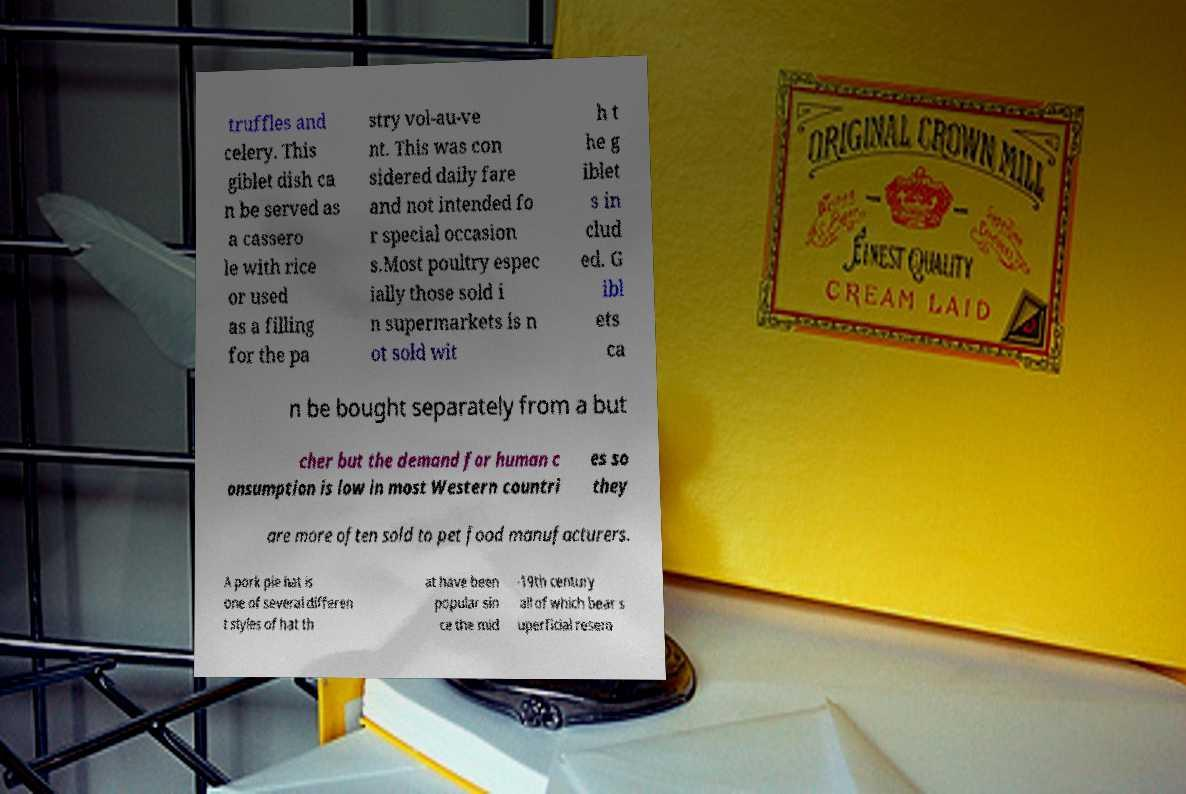Could you assist in decoding the text presented in this image and type it out clearly? truffles and celery. This giblet dish ca n be served as a cassero le with rice or used as a filling for the pa stry vol-au-ve nt. This was con sidered daily fare and not intended fo r special occasion s.Most poultry espec ially those sold i n supermarkets is n ot sold wit h t he g iblet s in clud ed. G ibl ets ca n be bought separately from a but cher but the demand for human c onsumption is low in most Western countri es so they are more often sold to pet food manufacturers. A pork pie hat is one of several differen t styles of hat th at have been popular sin ce the mid -19th century all of which bear s uperficial resem 